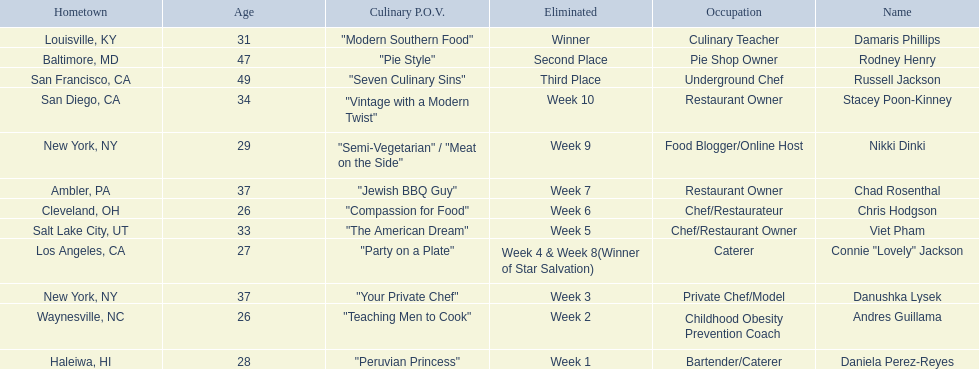Who are all of the contestants? Damaris Phillips, Rodney Henry, Russell Jackson, Stacey Poon-Kinney, Nikki Dinki, Chad Rosenthal, Chris Hodgson, Viet Pham, Connie "Lovely" Jackson, Danushka Lysek, Andres Guillama, Daniela Perez-Reyes. Which culinary p.o.v. is longer than vintage with a modern twist? "Semi-Vegetarian" / "Meat on the Side". Which contestant's p.o.v. is semi-vegetarian/meat on the side? Nikki Dinki. 